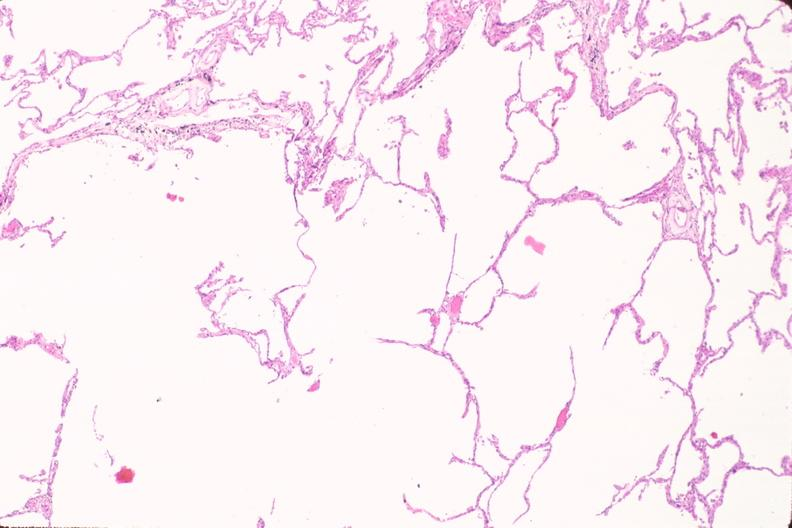s retroperitoneal leiomyosarcoma present?
Answer the question using a single word or phrase. No 